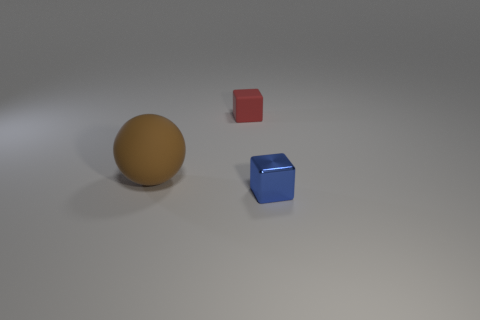Can you describe the colors and shapes present in this image? Certainly! The image showcases three distinct objects: a large brown sphere, a small red cube, and a small blue cube. The sphere's color resembles a tawny brown, while the cubes are primary colors—red and blue—providing a stark color contrast against a neutral background. How would you say the positioning of these objects affects the perception of the image? The positioning of the objects creates a sense of depth and spatial relationships. The large brown sphere, centered in the image, serves as an anchor point, while the smaller red and blue cubes are staggered in front, adding layers and contributing to a more dynamic composition. 